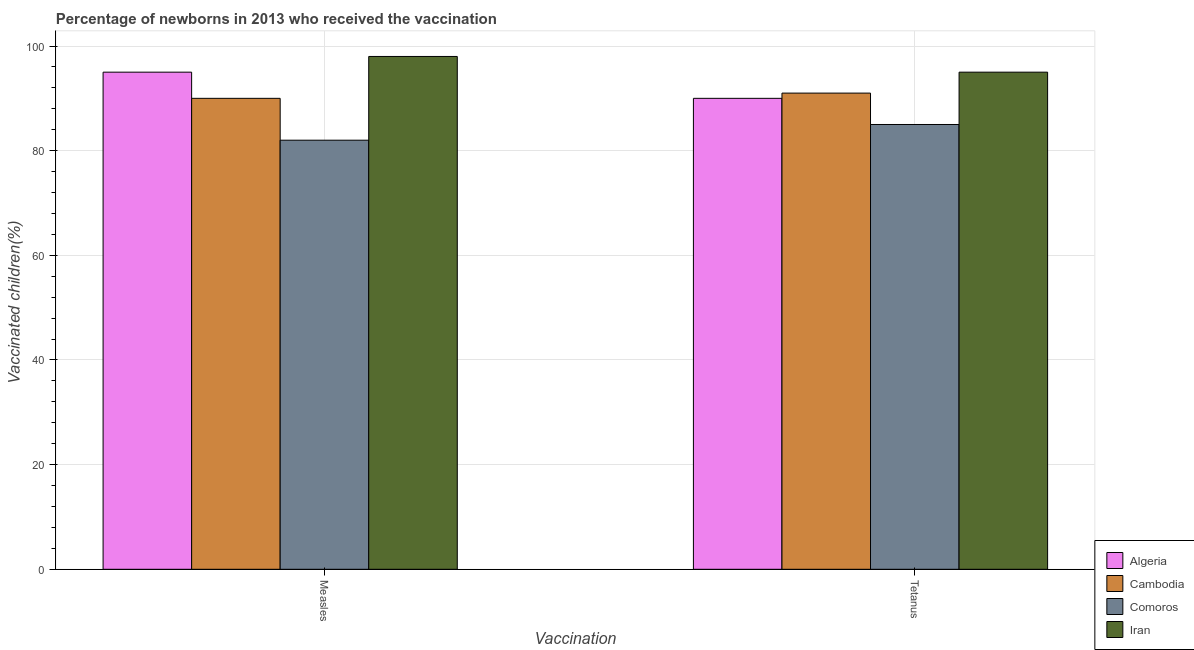How many groups of bars are there?
Ensure brevity in your answer.  2. Are the number of bars on each tick of the X-axis equal?
Provide a succinct answer. Yes. How many bars are there on the 2nd tick from the left?
Your answer should be compact. 4. What is the label of the 2nd group of bars from the left?
Make the answer very short. Tetanus. What is the percentage of newborns who received vaccination for tetanus in Algeria?
Your response must be concise. 90. Across all countries, what is the maximum percentage of newborns who received vaccination for tetanus?
Your response must be concise. 95. Across all countries, what is the minimum percentage of newborns who received vaccination for measles?
Provide a short and direct response. 82. In which country was the percentage of newborns who received vaccination for tetanus maximum?
Ensure brevity in your answer.  Iran. In which country was the percentage of newborns who received vaccination for measles minimum?
Your response must be concise. Comoros. What is the total percentage of newborns who received vaccination for measles in the graph?
Ensure brevity in your answer.  365. What is the difference between the percentage of newborns who received vaccination for tetanus in Cambodia and the percentage of newborns who received vaccination for measles in Algeria?
Offer a very short reply. -4. What is the average percentage of newborns who received vaccination for tetanus per country?
Offer a terse response. 90.25. What is the difference between the percentage of newborns who received vaccination for measles and percentage of newborns who received vaccination for tetanus in Cambodia?
Your answer should be compact. -1. What is the ratio of the percentage of newborns who received vaccination for tetanus in Cambodia to that in Algeria?
Provide a succinct answer. 1.01. Is the percentage of newborns who received vaccination for measles in Cambodia less than that in Algeria?
Give a very brief answer. Yes. In how many countries, is the percentage of newborns who received vaccination for measles greater than the average percentage of newborns who received vaccination for measles taken over all countries?
Your answer should be compact. 2. What does the 1st bar from the left in Measles represents?
Give a very brief answer. Algeria. What does the 2nd bar from the right in Tetanus represents?
Provide a succinct answer. Comoros. How many countries are there in the graph?
Provide a succinct answer. 4. What is the difference between two consecutive major ticks on the Y-axis?
Make the answer very short. 20. Are the values on the major ticks of Y-axis written in scientific E-notation?
Your answer should be very brief. No. Does the graph contain grids?
Your answer should be compact. Yes. Where does the legend appear in the graph?
Provide a short and direct response. Bottom right. What is the title of the graph?
Your answer should be compact. Percentage of newborns in 2013 who received the vaccination. Does "Equatorial Guinea" appear as one of the legend labels in the graph?
Your response must be concise. No. What is the label or title of the X-axis?
Provide a short and direct response. Vaccination. What is the label or title of the Y-axis?
Your answer should be very brief. Vaccinated children(%)
. What is the Vaccinated children(%)
 of Algeria in Measles?
Give a very brief answer. 95. What is the Vaccinated children(%)
 in Cambodia in Measles?
Your answer should be compact. 90. What is the Vaccinated children(%)
 of Comoros in Measles?
Offer a very short reply. 82. What is the Vaccinated children(%)
 of Iran in Measles?
Your response must be concise. 98. What is the Vaccinated children(%)
 in Algeria in Tetanus?
Offer a terse response. 90. What is the Vaccinated children(%)
 in Cambodia in Tetanus?
Ensure brevity in your answer.  91. Across all Vaccination, what is the maximum Vaccinated children(%)
 of Cambodia?
Provide a succinct answer. 91. Across all Vaccination, what is the maximum Vaccinated children(%)
 in Comoros?
Offer a very short reply. 85. Across all Vaccination, what is the minimum Vaccinated children(%)
 of Algeria?
Your response must be concise. 90. Across all Vaccination, what is the minimum Vaccinated children(%)
 of Cambodia?
Your response must be concise. 90. Across all Vaccination, what is the minimum Vaccinated children(%)
 of Comoros?
Your answer should be very brief. 82. Across all Vaccination, what is the minimum Vaccinated children(%)
 in Iran?
Your response must be concise. 95. What is the total Vaccinated children(%)
 of Algeria in the graph?
Your response must be concise. 185. What is the total Vaccinated children(%)
 of Cambodia in the graph?
Provide a short and direct response. 181. What is the total Vaccinated children(%)
 in Comoros in the graph?
Provide a short and direct response. 167. What is the total Vaccinated children(%)
 of Iran in the graph?
Give a very brief answer. 193. What is the difference between the Vaccinated children(%)
 of Algeria in Measles and that in Tetanus?
Provide a succinct answer. 5. What is the difference between the Vaccinated children(%)
 of Cambodia in Measles and that in Tetanus?
Keep it short and to the point. -1. What is the difference between the Vaccinated children(%)
 in Iran in Measles and that in Tetanus?
Your answer should be very brief. 3. What is the difference between the Vaccinated children(%)
 of Algeria in Measles and the Vaccinated children(%)
 of Iran in Tetanus?
Provide a succinct answer. 0. What is the difference between the Vaccinated children(%)
 in Cambodia in Measles and the Vaccinated children(%)
 in Iran in Tetanus?
Your response must be concise. -5. What is the average Vaccinated children(%)
 of Algeria per Vaccination?
Make the answer very short. 92.5. What is the average Vaccinated children(%)
 in Cambodia per Vaccination?
Your answer should be very brief. 90.5. What is the average Vaccinated children(%)
 of Comoros per Vaccination?
Your response must be concise. 83.5. What is the average Vaccinated children(%)
 in Iran per Vaccination?
Ensure brevity in your answer.  96.5. What is the difference between the Vaccinated children(%)
 in Algeria and Vaccinated children(%)
 in Cambodia in Measles?
Ensure brevity in your answer.  5. What is the difference between the Vaccinated children(%)
 in Cambodia and Vaccinated children(%)
 in Iran in Measles?
Offer a very short reply. -8. What is the difference between the Vaccinated children(%)
 of Cambodia and Vaccinated children(%)
 of Comoros in Tetanus?
Offer a very short reply. 6. What is the difference between the Vaccinated children(%)
 of Cambodia and Vaccinated children(%)
 of Iran in Tetanus?
Your answer should be very brief. -4. What is the ratio of the Vaccinated children(%)
 in Algeria in Measles to that in Tetanus?
Offer a terse response. 1.06. What is the ratio of the Vaccinated children(%)
 in Comoros in Measles to that in Tetanus?
Provide a succinct answer. 0.96. What is the ratio of the Vaccinated children(%)
 of Iran in Measles to that in Tetanus?
Offer a very short reply. 1.03. What is the difference between the highest and the second highest Vaccinated children(%)
 in Comoros?
Give a very brief answer. 3. What is the difference between the highest and the lowest Vaccinated children(%)
 of Algeria?
Give a very brief answer. 5. 